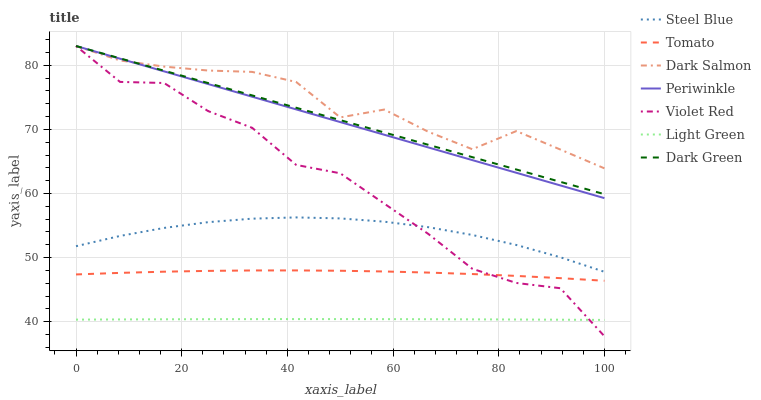Does Light Green have the minimum area under the curve?
Answer yes or no. Yes. Does Dark Salmon have the maximum area under the curve?
Answer yes or no. Yes. Does Violet Red have the minimum area under the curve?
Answer yes or no. No. Does Violet Red have the maximum area under the curve?
Answer yes or no. No. Is Periwinkle the smoothest?
Answer yes or no. Yes. Is Violet Red the roughest?
Answer yes or no. Yes. Is Steel Blue the smoothest?
Answer yes or no. No. Is Steel Blue the roughest?
Answer yes or no. No. Does Violet Red have the lowest value?
Answer yes or no. Yes. Does Steel Blue have the lowest value?
Answer yes or no. No. Does Dark Green have the highest value?
Answer yes or no. Yes. Does Steel Blue have the highest value?
Answer yes or no. No. Is Light Green less than Steel Blue?
Answer yes or no. Yes. Is Tomato greater than Light Green?
Answer yes or no. Yes. Does Violet Red intersect Periwinkle?
Answer yes or no. Yes. Is Violet Red less than Periwinkle?
Answer yes or no. No. Is Violet Red greater than Periwinkle?
Answer yes or no. No. Does Light Green intersect Steel Blue?
Answer yes or no. No. 